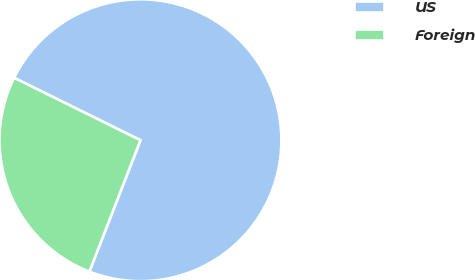Convert chart. <chart><loc_0><loc_0><loc_500><loc_500><pie_chart><fcel>US<fcel>Foreign<nl><fcel>73.6%<fcel>26.4%<nl></chart> 